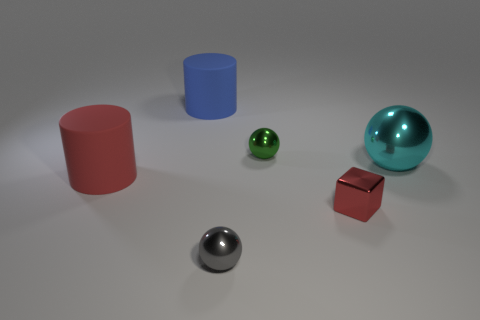How big is the red cylinder?
Keep it short and to the point. Large. Are there more tiny metal cubes to the left of the red rubber object than green objects that are behind the small gray sphere?
Keep it short and to the point. No. Are there any tiny things in front of the tiny red block?
Your answer should be very brief. Yes. Are there any green cylinders that have the same size as the green sphere?
Offer a very short reply. No. What color is the cylinder that is made of the same material as the large blue thing?
Your answer should be very brief. Red. What is the material of the small block?
Ensure brevity in your answer.  Metal. What is the shape of the big red thing?
Provide a short and direct response. Cylinder. How many other small metal blocks are the same color as the small metal cube?
Give a very brief answer. 0. There is a small ball that is left of the tiny ball behind the small sphere in front of the big shiny thing; what is it made of?
Give a very brief answer. Metal. What number of blue objects are rubber cylinders or small cylinders?
Ensure brevity in your answer.  1. 